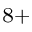<formula> <loc_0><loc_0><loc_500><loc_500>^ { 8 + }</formula> 